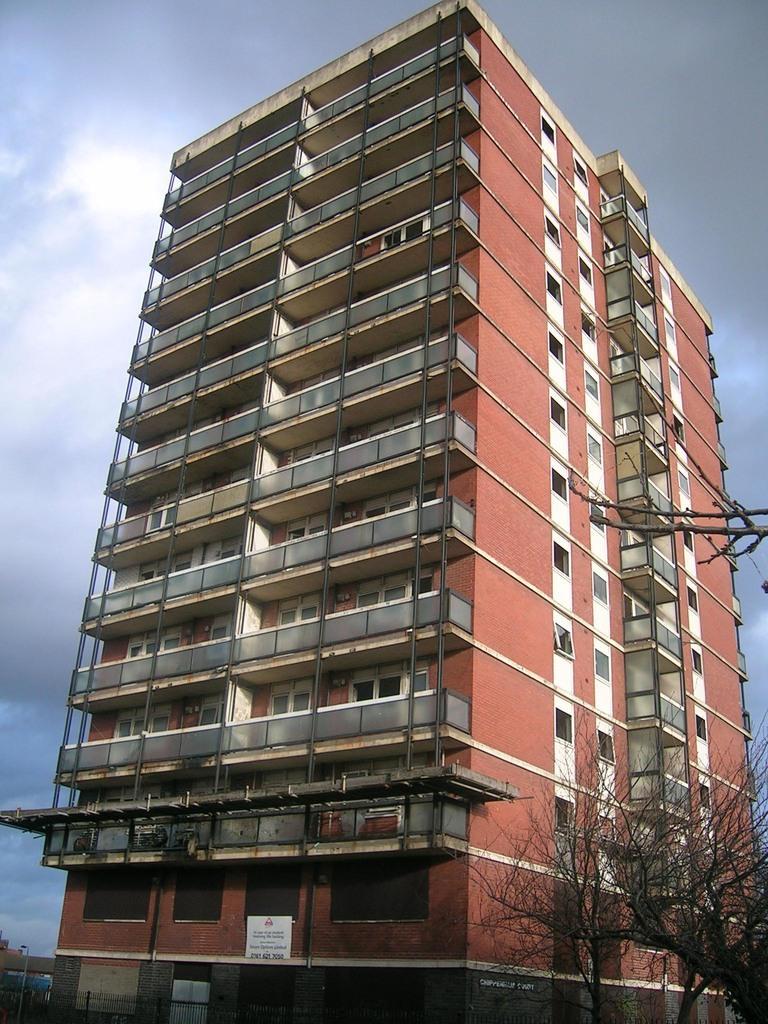Can you describe this image briefly? In this image I see a building on which there are number of windows and I see a tree over here and I see the fencing. In the background I see the sky which is cloudy and I see stems over here. 